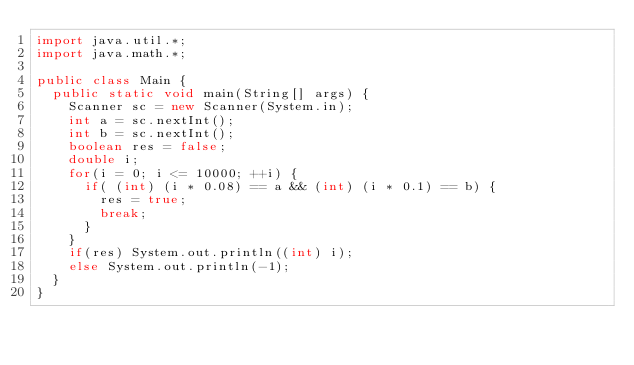Convert code to text. <code><loc_0><loc_0><loc_500><loc_500><_Java_>import java.util.*;
import java.math.*;
 
public class Main {
  public static void main(String[] args) {
    Scanner sc = new Scanner(System.in);
    int a = sc.nextInt();
    int b = sc.nextInt();
    boolean res = false;
    double i;
    for(i = 0; i <= 10000; ++i) {
      if( (int) (i * 0.08) == a && (int) (i * 0.1) == b) {
        res = true;
        break;
      }
    }
    if(res) System.out.println((int) i); 
    else System.out.println(-1);
  }
}</code> 